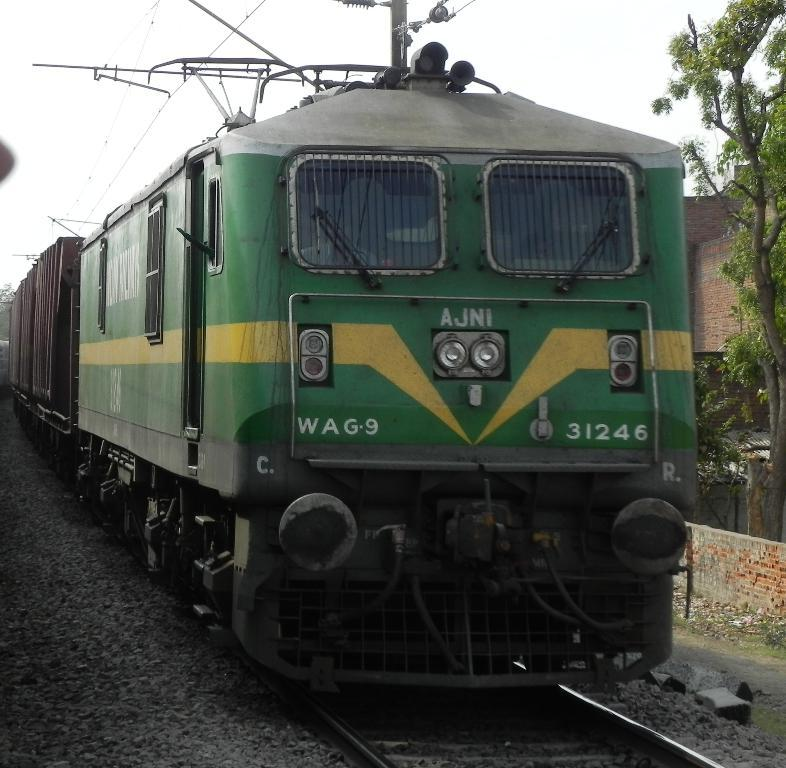What is the main subject of the image? There is a train in the image. What is the train's position in relation to the track? The train is on a track. What can be seen on the right side of the image? There are trees and walls on the right side of the image. What is visible in the background of the image? The sky is visible in the background of the image. What type of match is being played in the image? There is no match being played in the image; it features a train on a track. Can you tell me how many bubbles are floating around the train in the image? There are no bubbles present in the image; it features a train on a track with trees, walls, and the sky visible in the background. 